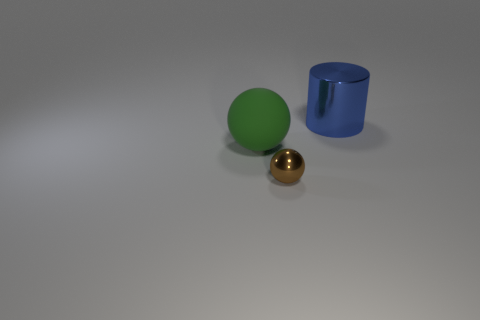How many other objects are there of the same color as the large shiny object?
Your answer should be very brief. 0. The metal thing in front of the big metallic object is what color?
Keep it short and to the point. Brown. Are there any green objects of the same size as the cylinder?
Offer a very short reply. Yes. There is a blue object that is the same size as the green matte object; what is its material?
Ensure brevity in your answer.  Metal. What number of things are either metallic objects that are in front of the large blue metallic object or large things to the left of the large blue cylinder?
Give a very brief answer. 2. Are there any tiny gray matte things that have the same shape as the brown object?
Provide a short and direct response. No. What number of shiny things are either blue cylinders or large green spheres?
Keep it short and to the point. 1. The large blue thing is what shape?
Give a very brief answer. Cylinder. What number of tiny things have the same material as the small ball?
Keep it short and to the point. 0. There is a thing that is the same material as the big blue cylinder; what is its color?
Ensure brevity in your answer.  Brown. 